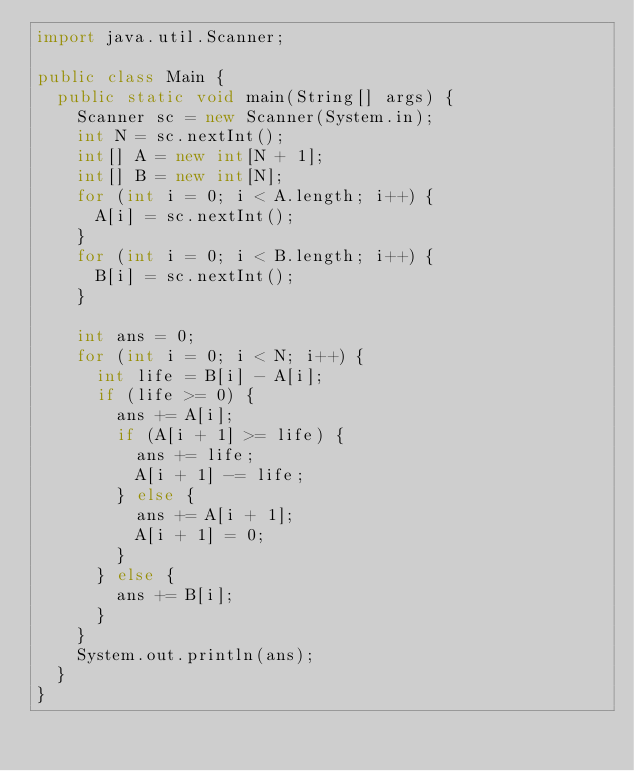<code> <loc_0><loc_0><loc_500><loc_500><_Java_>import java.util.Scanner;

public class Main {
  public static void main(String[] args) {
    Scanner sc = new Scanner(System.in);
    int N = sc.nextInt();
    int[] A = new int[N + 1];
    int[] B = new int[N];
    for (int i = 0; i < A.length; i++) {
      A[i] = sc.nextInt();
    }
    for (int i = 0; i < B.length; i++) {
      B[i] = sc.nextInt();
    }

    int ans = 0;
    for (int i = 0; i < N; i++) {
      int life = B[i] - A[i];
      if (life >= 0) {
        ans += A[i];
        if (A[i + 1] >= life) {
          ans += life;
          A[i + 1] -= life;
        } else {
          ans += A[i + 1];
          A[i + 1] = 0;
        }
      } else {
        ans += B[i];
      }
    }
    System.out.println(ans);
  }
}</code> 